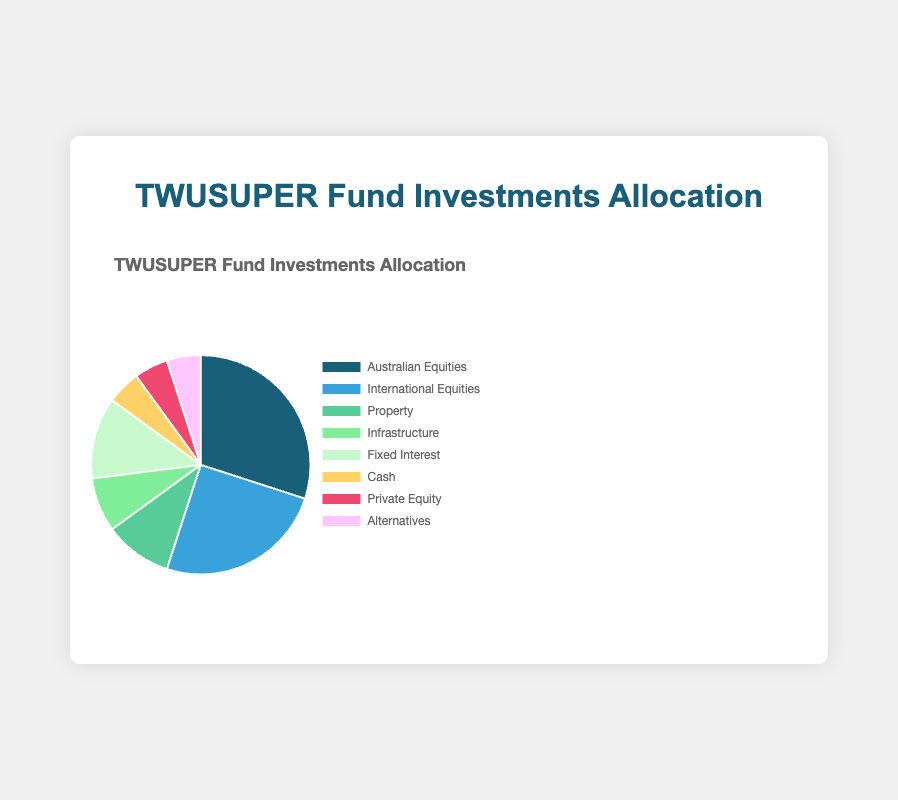What percentage of the TWUSUPER Fund is allocated to equities (Australian and International combined)? The allocation to Australian Equities is 30% and to International Equities is 25%. Adding these together gives 30% + 25% = 55%.
Answer: 55% Which investment category has the smallest allocation? The Figure shows that "Cash," "Private Equity," and "Alternatives" each have a 5% allocation, which is the smallest among all categories.
Answer: Cash, Private Equity, and Alternatives What is the difference in allocation between Australian Equities and Infrastructure? Allocation for Australian Equities is 30%, and for Infrastructure is 8%. The difference is 30% - 8% = 22%.
Answer: 22% How does the allocation to Fixed Interest compare to that of Property? Fixed Interest has an allocation of 12%, while Property has 10%. Fixed Interest is allocated 2% more than Property.
Answer: 2% more What is the total allocation percentage for Property, Infrastructure, and Alternatives combined? Property has 10%, Infrastructure 8%, and Alternatives 5%. Adding these gives 10% + 8% + 5% = 23%.
Answer: 23% What is the visual color representation for International Equities? According to the figure, the color representing International Equities is blue.
Answer: Blue If you were to describe the allocation to Property in terms of a fraction of the total fund, what would it be? Property is allocated 10% of the total fund. As a fraction, this would be 10/100, which simplifies to 1/10 of the total fund.
Answer: 1/10 Which has a greater allocation, Cash or Fixed Interest, and by how much? Cash has 5% and Fixed Interest has 12%. The difference is 12% - 5% = 7%. Fixed Interest has a 7% greater allocation than Cash.
Answer: Fixed Interest by 7% Is the combined allocation to Private Equity and Alternatives greater than that to Infrastructure? Private Equity is 5%, and Alternatives is 5%, totaling 5% + 5% = 10%. Infrastructure is 8%. Since 10% > 8%, the combined allocation is greater.
Answer: Yes How many categories have an allocation of exactly 5%? The categories with exactly 5% allocation are Cash, Private Equity, and Alternatives. That makes a total of 3 categories.
Answer: 3 